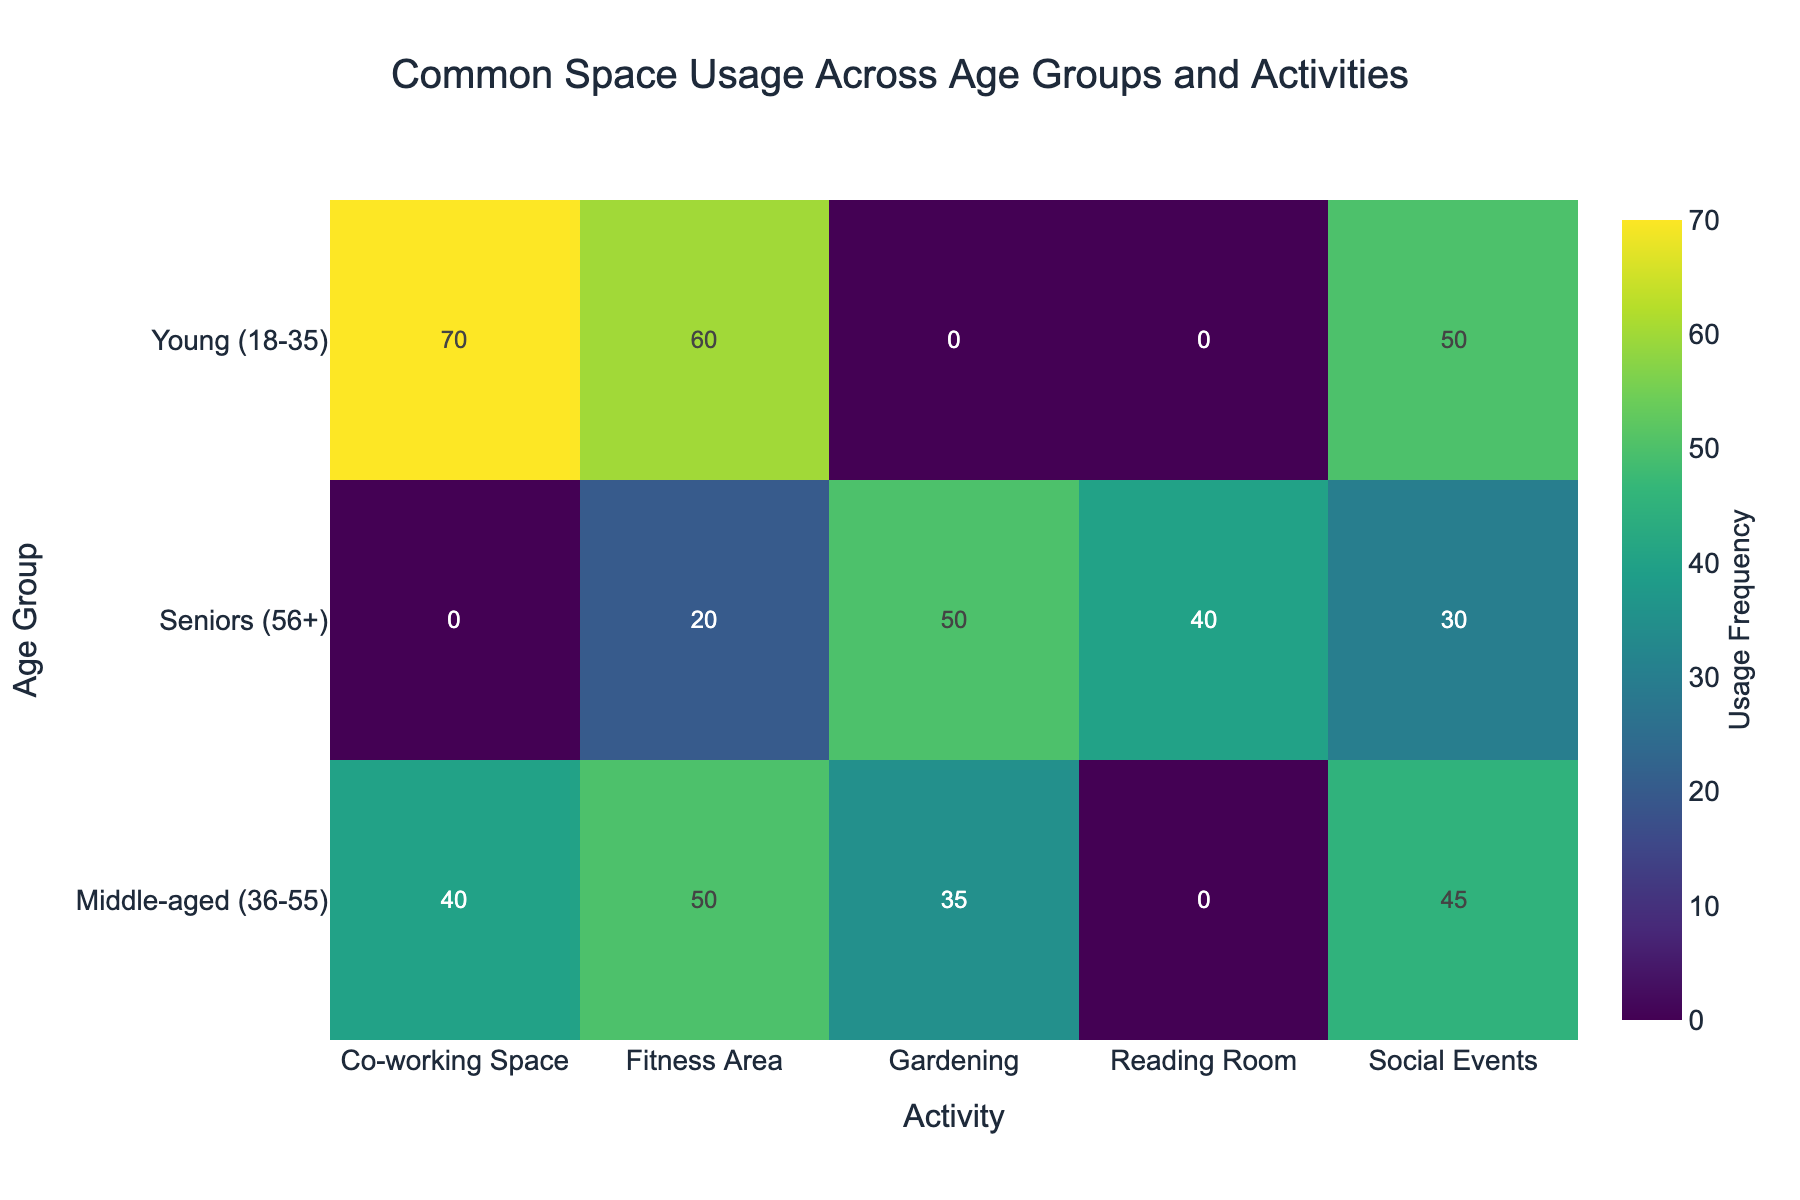What is the title of the plot? The title is often placed at the top of the plot and is typically larger and more prominent than the other text. It provides the main topic of the visualization.
Answer: Common Space Usage Across Age Groups and Activities Which age group uses the co-working space the most? Look for the highest usage frequency in the co-working space category by comparing the values for each age group.
Answer: Young (18-35) What’s the usage frequency of fitness areas for middle-aged individuals? Identify the row for middle-aged individuals and look across the activities to find the frequency value for the fitness area.
Answer: 50 How many activities are listed for seniors (56+)? Count the different activities listed under the senior age group row.
Answer: 4 Which activity has the lowest usage frequency for seniors (56+)? Find the lowest number among the frequencies for each activity in the row corresponding to seniors.
Answer: Fitness Area What is the sum of usage frequencies for gardening across all age groups? Find the gardening frequency for each age group and sum them up: 0 (Young) + 35 (Middle-aged) + 50 (Seniors).
Answer: 85 Compare the usage frequency of social events between young adults and seniors. Which group uses it more? Look at the social events frequency for both age groups and compare: 50 for Young and 30 for Seniors.
Answer: Young (18-35) What is the average usage frequency of the fitness area for all age groups? Add the fitness area usage frequencies for all age groups and divide by the number of groups: (60 + 50 + 20) / 3.
Answer: 43.33 Which activity is exclusively used by seniors and no other age group? Look for an activity that only has a usage frequency listed for seniors.
Answer: Reading Room What is the difference in usage frequency of social events between young adults and middle-aged individuals? Subtract the middle-aged value from the young adults value: 50 (Young) - 45 (Middle-aged).
Answer: 5 